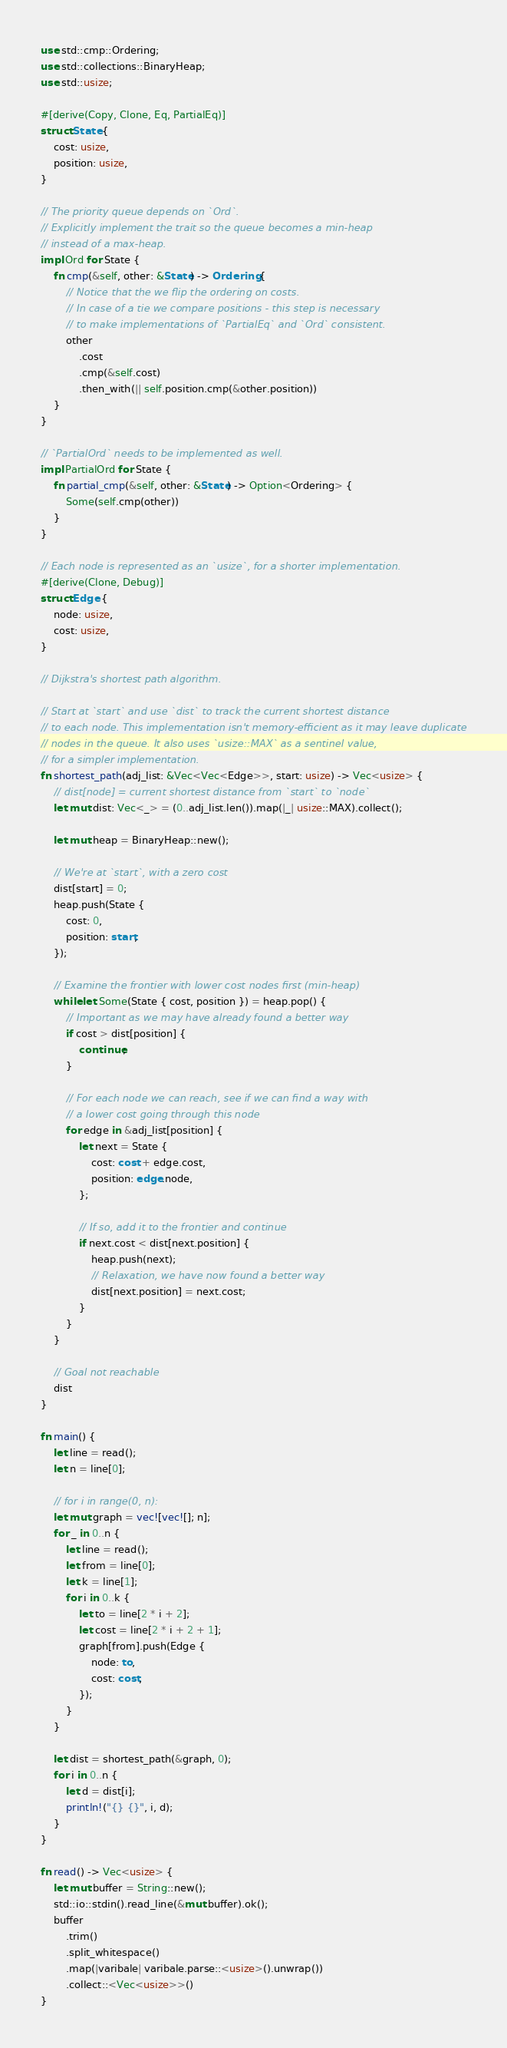Convert code to text. <code><loc_0><loc_0><loc_500><loc_500><_Rust_>use std::cmp::Ordering;
use std::collections::BinaryHeap;
use std::usize;

#[derive(Copy, Clone, Eq, PartialEq)]
struct State {
    cost: usize,
    position: usize,
}

// The priority queue depends on `Ord`.
// Explicitly implement the trait so the queue becomes a min-heap
// instead of a max-heap.
impl Ord for State {
    fn cmp(&self, other: &State) -> Ordering {
        // Notice that the we flip the ordering on costs.
        // In case of a tie we compare positions - this step is necessary
        // to make implementations of `PartialEq` and `Ord` consistent.
        other
            .cost
            .cmp(&self.cost)
            .then_with(|| self.position.cmp(&other.position))
    }
}

// `PartialOrd` needs to be implemented as well.
impl PartialOrd for State {
    fn partial_cmp(&self, other: &State) -> Option<Ordering> {
        Some(self.cmp(other))
    }
}

// Each node is represented as an `usize`, for a shorter implementation.
#[derive(Clone, Debug)]
struct Edge {
    node: usize,
    cost: usize,
}

// Dijkstra's shortest path algorithm.

// Start at `start` and use `dist` to track the current shortest distance
// to each node. This implementation isn't memory-efficient as it may leave duplicate
// nodes in the queue. It also uses `usize::MAX` as a sentinel value,
// for a simpler implementation.
fn shortest_path(adj_list: &Vec<Vec<Edge>>, start: usize) -> Vec<usize> {
    // dist[node] = current shortest distance from `start` to `node`
    let mut dist: Vec<_> = (0..adj_list.len()).map(|_| usize::MAX).collect();

    let mut heap = BinaryHeap::new();

    // We're at `start`, with a zero cost
    dist[start] = 0;
    heap.push(State {
        cost: 0,
        position: start,
    });

    // Examine the frontier with lower cost nodes first (min-heap)
    while let Some(State { cost, position }) = heap.pop() {
        // Important as we may have already found a better way
        if cost > dist[position] {
            continue;
        }

        // For each node we can reach, see if we can find a way with
        // a lower cost going through this node
        for edge in &adj_list[position] {
            let next = State {
                cost: cost + edge.cost,
                position: edge.node,
            };

            // If so, add it to the frontier and continue
            if next.cost < dist[next.position] {
                heap.push(next);
                // Relaxation, we have now found a better way
                dist[next.position] = next.cost;
            }
        }
    }

    // Goal not reachable
    dist
}

fn main() {
    let line = read();
    let n = line[0];

    // for i in range(0, n):
    let mut graph = vec![vec![]; n];
    for _ in 0..n {
        let line = read();
        let from = line[0];
        let k = line[1];
        for i in 0..k {
            let to = line[2 * i + 2];
            let cost = line[2 * i + 2 + 1];
            graph[from].push(Edge {
                node: to,
                cost: cost,
            });
        }
    }

    let dist = shortest_path(&graph, 0);
    for i in 0..n {
        let d = dist[i];
        println!("{} {}", i, d);
    }
}

fn read() -> Vec<usize> {
    let mut buffer = String::new();
    std::io::stdin().read_line(&mut buffer).ok();
    buffer
        .trim()
        .split_whitespace()
        .map(|varibale| varibale.parse::<usize>().unwrap())
        .collect::<Vec<usize>>()
}

</code> 